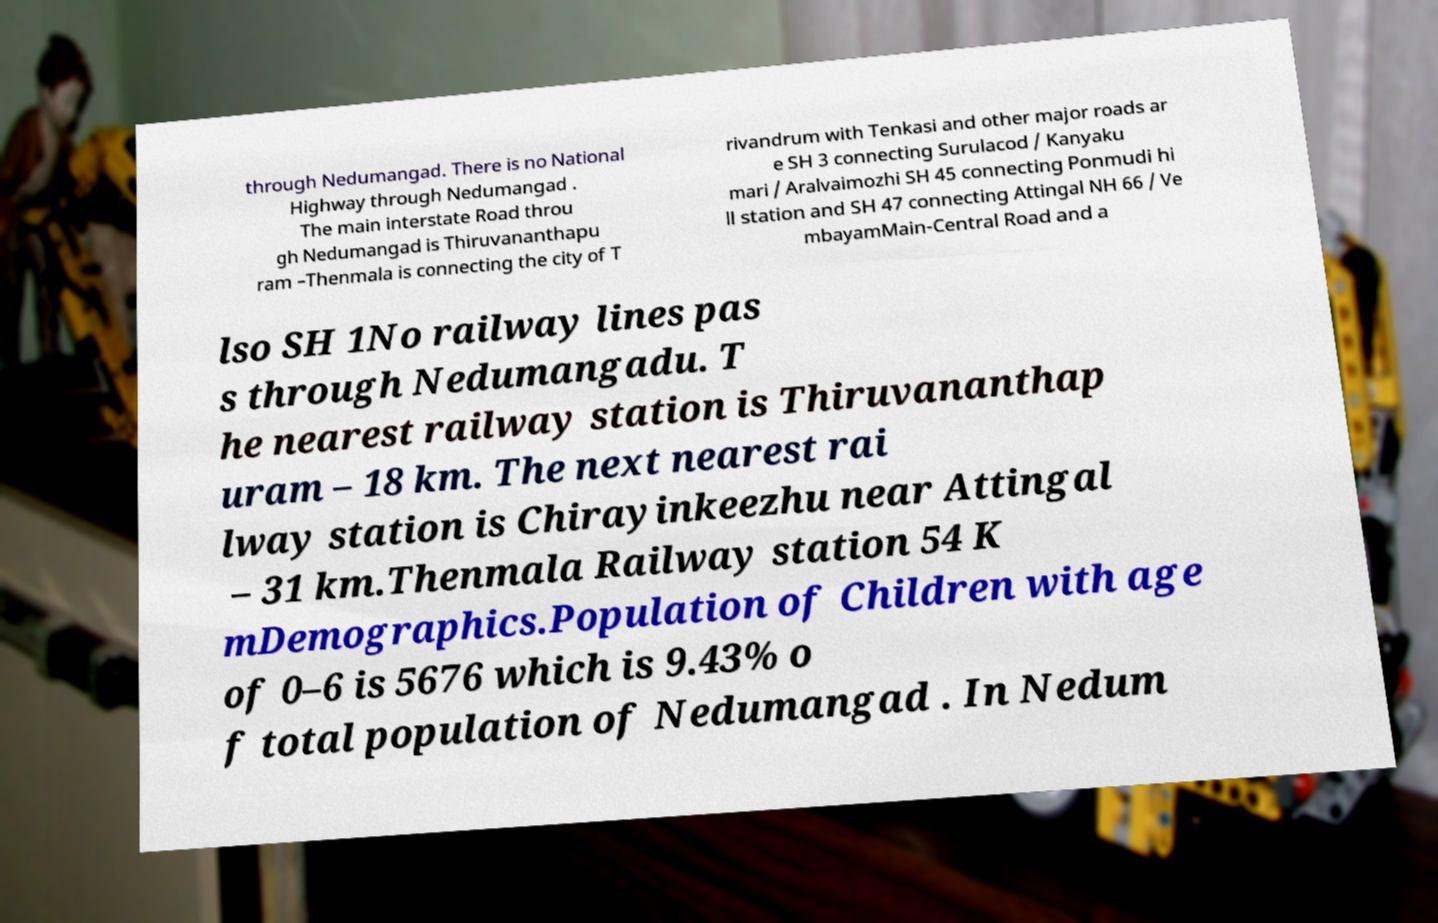For documentation purposes, I need the text within this image transcribed. Could you provide that? through Nedumangad. There is no National Highway through Nedumangad . The main interstate Road throu gh Nedumangad is Thiruvananthapu ram –Thenmala is connecting the city of T rivandrum with Tenkasi and other major roads ar e SH 3 connecting Surulacod / Kanyaku mari / Aralvaimozhi SH 45 connecting Ponmudi hi ll station and SH 47 connecting Attingal NH 66 / Ve mbayamMain-Central Road and a lso SH 1No railway lines pas s through Nedumangadu. T he nearest railway station is Thiruvananthap uram – 18 km. The next nearest rai lway station is Chirayinkeezhu near Attingal – 31 km.Thenmala Railway station 54 K mDemographics.Population of Children with age of 0–6 is 5676 which is 9.43% o f total population of Nedumangad . In Nedum 